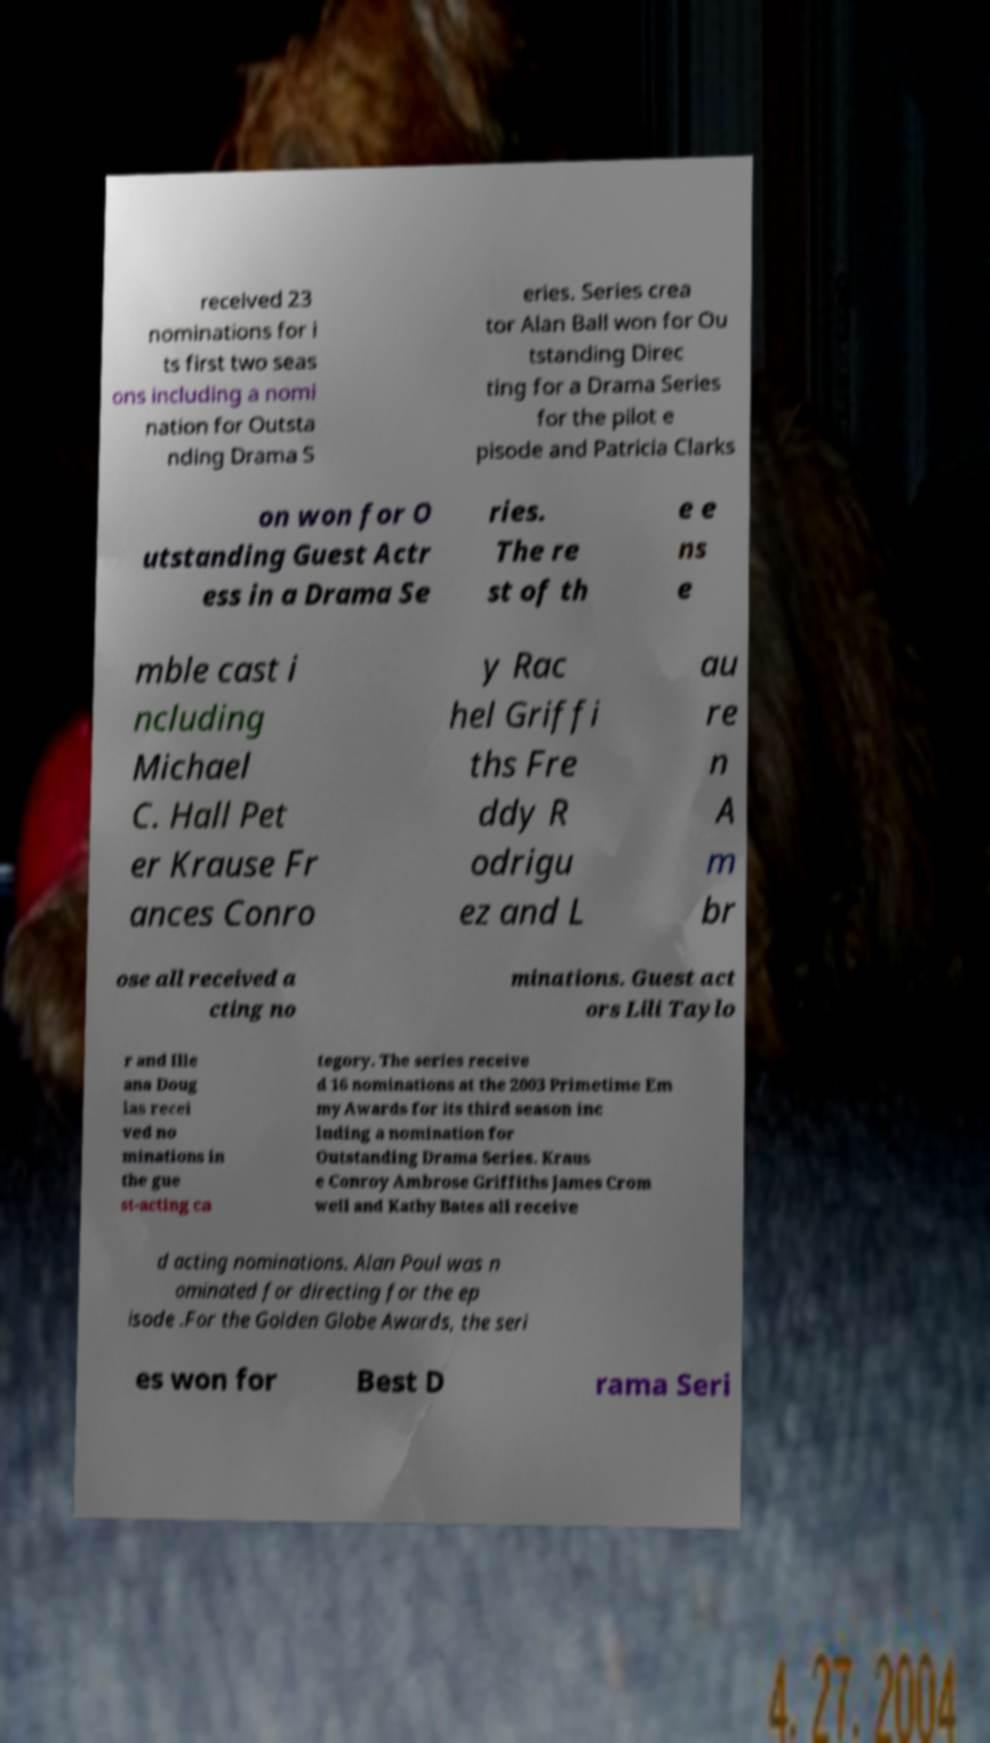Please read and relay the text visible in this image. What does it say? received 23 nominations for i ts first two seas ons including a nomi nation for Outsta nding Drama S eries. Series crea tor Alan Ball won for Ou tstanding Direc ting for a Drama Series for the pilot e pisode and Patricia Clarks on won for O utstanding Guest Actr ess in a Drama Se ries. The re st of th e e ns e mble cast i ncluding Michael C. Hall Pet er Krause Fr ances Conro y Rac hel Griffi ths Fre ddy R odrigu ez and L au re n A m br ose all received a cting no minations. Guest act ors Lili Taylo r and Ille ana Doug las recei ved no minations in the gue st-acting ca tegory. The series receive d 16 nominations at the 2003 Primetime Em my Awards for its third season inc luding a nomination for Outstanding Drama Series. Kraus e Conroy Ambrose Griffiths James Crom well and Kathy Bates all receive d acting nominations. Alan Poul was n ominated for directing for the ep isode .For the Golden Globe Awards, the seri es won for Best D rama Seri 